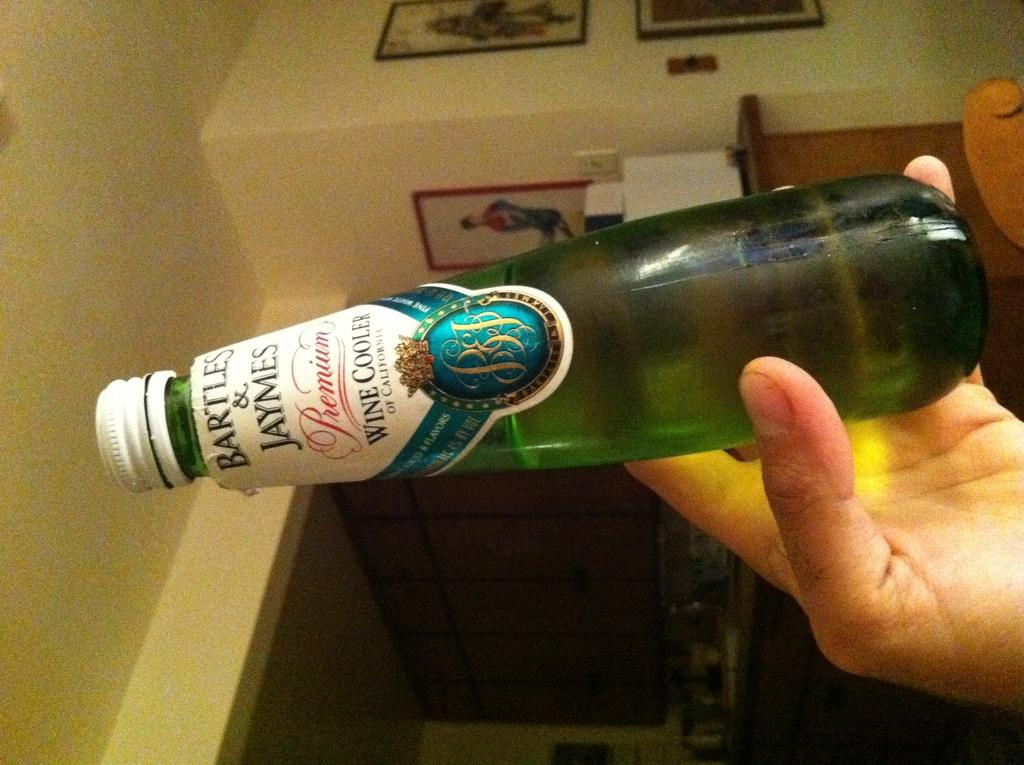What is the person in the image holding? The person is holding a bottle in the image. What can be seen on the wall in the image? There are pictures with frames on the wall in the image. What is located on the table in the image? There are objects on a table in the image. What type of items can be seen in the room in the image? There is furniture in the image. How many balls are resting on the furniture in the image? There are no balls visible in the image, so it is not possible to determine how many might be resting on the furniture. 